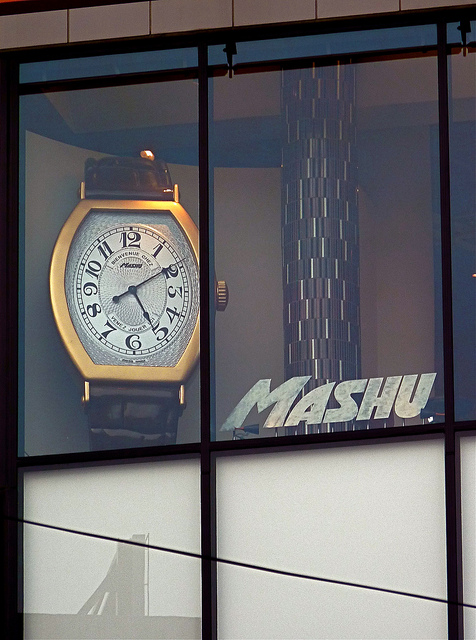Please transcribe the text in this image. MASHU 6 12 3 6 10 8 7 5 4 2 1 11 